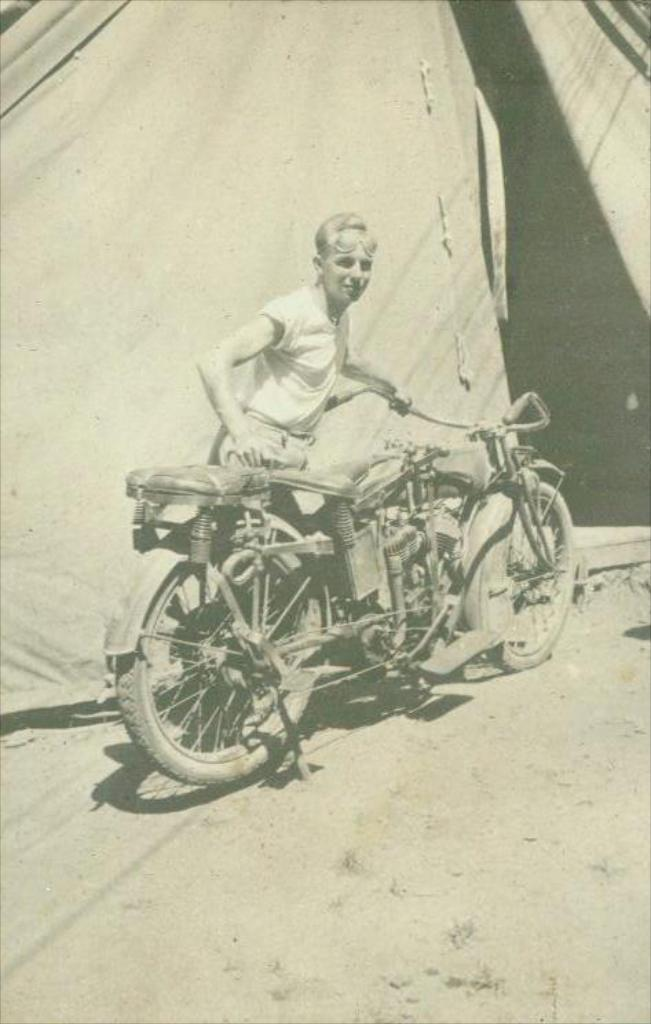What is the main subject of the image? There is a person in the image. What is the person doing in the image? The person is standing. What is the person holding in the image? The person is holding a vehicle. What type of shelter is visible in the image? There is a tent in the image. What type of sponge can be seen being used to gain knowledge in the image? There is no sponge or activity related to gaining knowledge present in the image. 